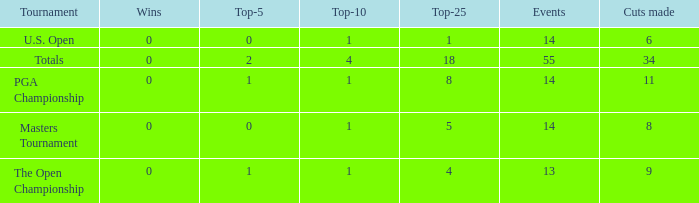What is the sum of wins when events is 13 and top-5 is less than 1? None. 